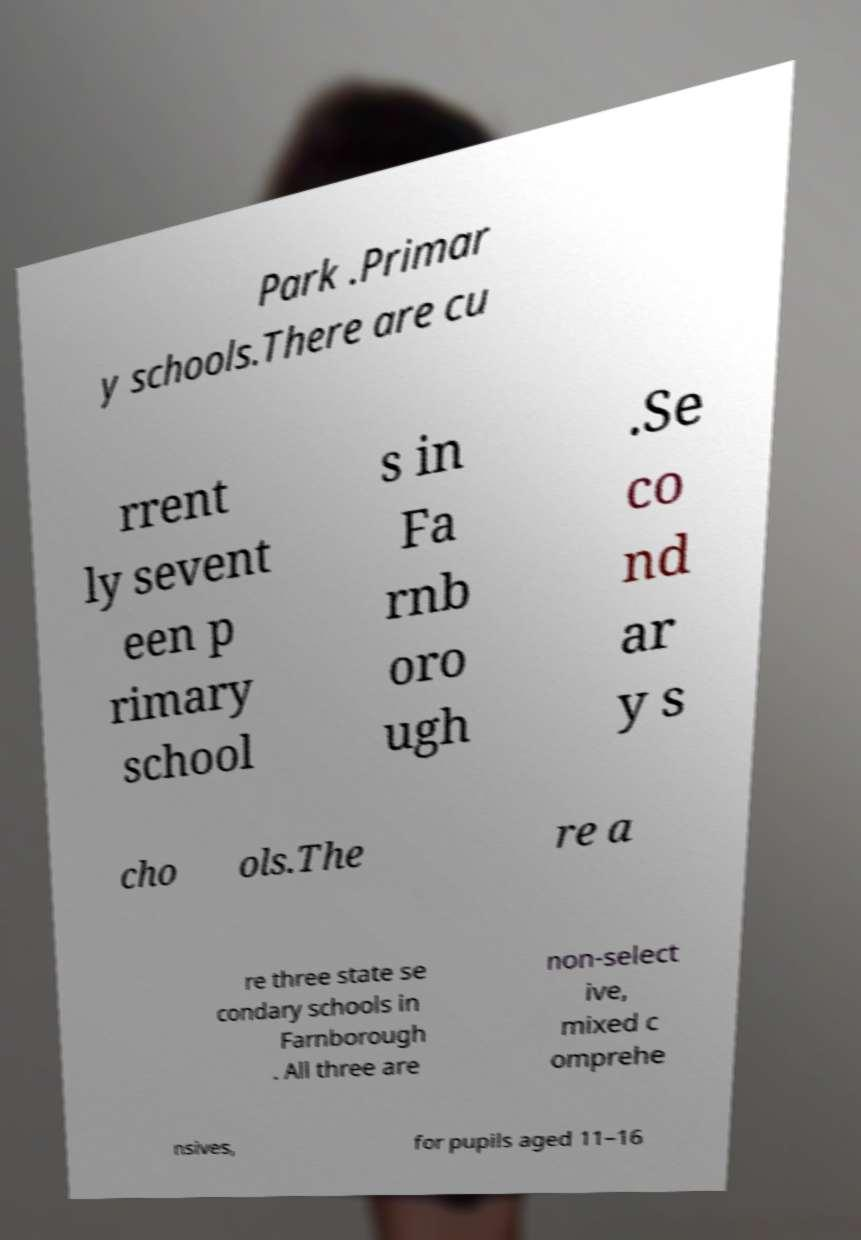What messages or text are displayed in this image? I need them in a readable, typed format. Park .Primar y schools.There are cu rrent ly sevent een p rimary school s in Fa rnb oro ugh .Se co nd ar y s cho ols.The re a re three state se condary schools in Farnborough . All three are non-select ive, mixed c omprehe nsives, for pupils aged 11–16 